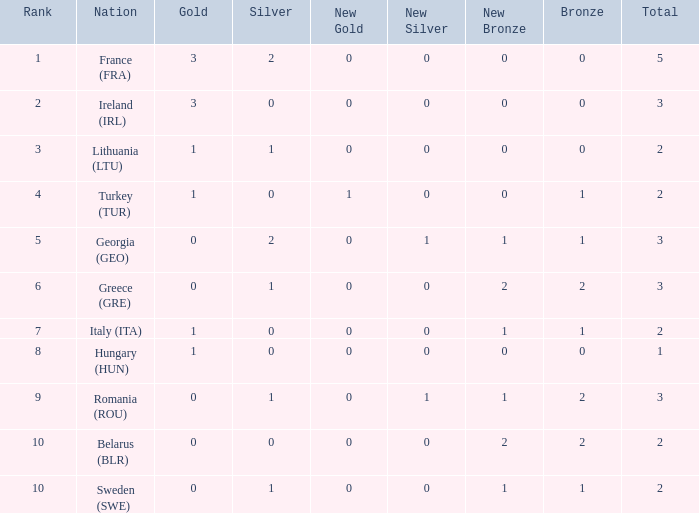What's the rank of Turkey (TUR) with a total more than 2? 0.0. 